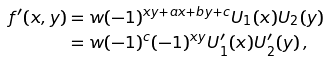Convert formula to latex. <formula><loc_0><loc_0><loc_500><loc_500>f ^ { \prime } ( x , y ) & = w ( - 1 ) ^ { x y + a x + b y + c } U _ { 1 } ( x ) U _ { 2 } ( y ) \\ & = w ( - 1 ) ^ { c } ( - 1 ) ^ { x y } U ^ { \prime } _ { 1 } ( x ) U ^ { \prime } _ { 2 } ( y ) \, ,</formula> 